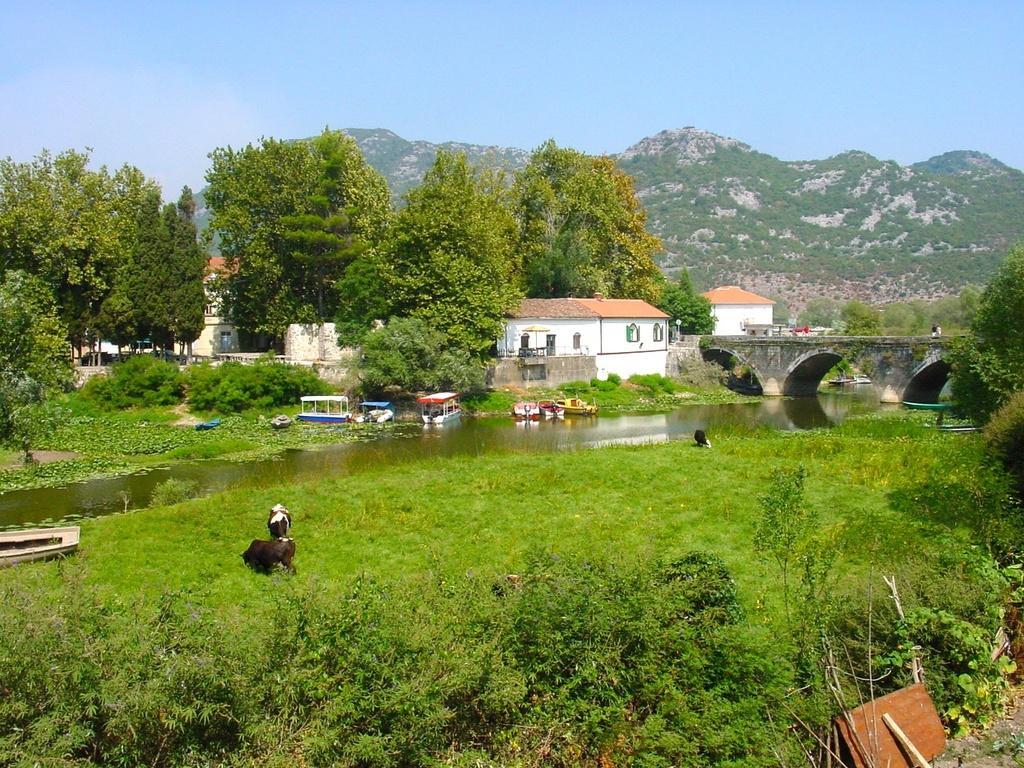Could you give a brief overview of what you see in this image? In this given image, We can see a couple of trees, mountains, a small houses, few boats, small river after that a bridge, We can see a goat sitting. 